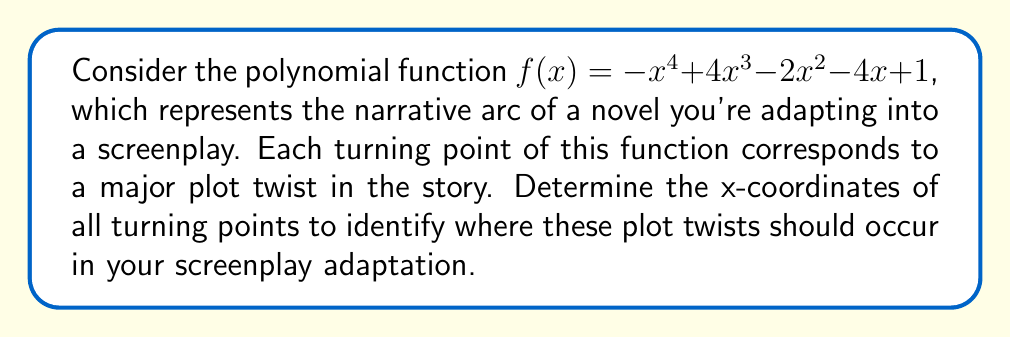Could you help me with this problem? To find the turning points of the polynomial function, we need to follow these steps:

1) First, we find the derivative of $f(x)$:
   $f'(x) = -4x^3 + 12x^2 - 4x - 4$

2) The turning points occur where $f'(x) = 0$, so we need to solve the equation:
   $-4x^3 + 12x^2 - 4x - 4 = 0$

3) Factor out -4:
   $-4(x^3 - 3x^2 + x + 1) = 0$

4) Divide both sides by -4:
   $x^3 - 3x^2 + x + 1 = 0$

5) This cubic equation doesn't have obvious factors, so we need to use the cubic formula or a graphing calculator to find its roots. The roots are approximately:

   $x_1 \approx -0.43$
   $x_2 \approx 1.21$
   $x_3 \approx 2.22$

6) These x-values represent the turning points of the original function $f(x)$, which correspond to the major plot twists in the narrative.

In the context of adapting a novel to a screenplay, these turning points suggest that significant plot twists should occur at about 43% into the story (rising action), 121% (which isn't possible in a linear narrative, so this would be near the climax), and 222% (which is also not possible, so this would be ignored or could represent a post-credits scene in a film adaptation).
Answer: $x \approx -0.43, 1.21, 2.22$ 